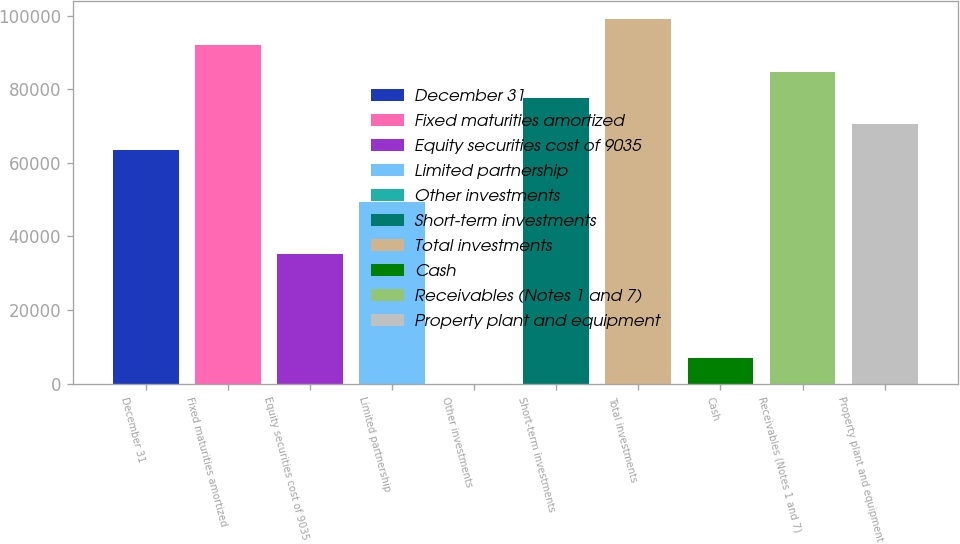<chart> <loc_0><loc_0><loc_500><loc_500><bar_chart><fcel>December 31<fcel>Fixed maturities amortized<fcel>Equity securities cost of 9035<fcel>Limited partnership<fcel>Other investments<fcel>Short-term investments<fcel>Total investments<fcel>Cash<fcel>Receivables (Notes 1 and 7)<fcel>Property plant and equipment<nl><fcel>63611.2<fcel>91868.7<fcel>35353.8<fcel>49482.5<fcel>32<fcel>77740<fcel>98933<fcel>7096.36<fcel>84804.3<fcel>70675.6<nl></chart> 